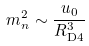<formula> <loc_0><loc_0><loc_500><loc_500>m _ { n } ^ { 2 } \sim \frac { u _ { 0 } } { R _ { \text {D4} } ^ { 3 } }</formula> 